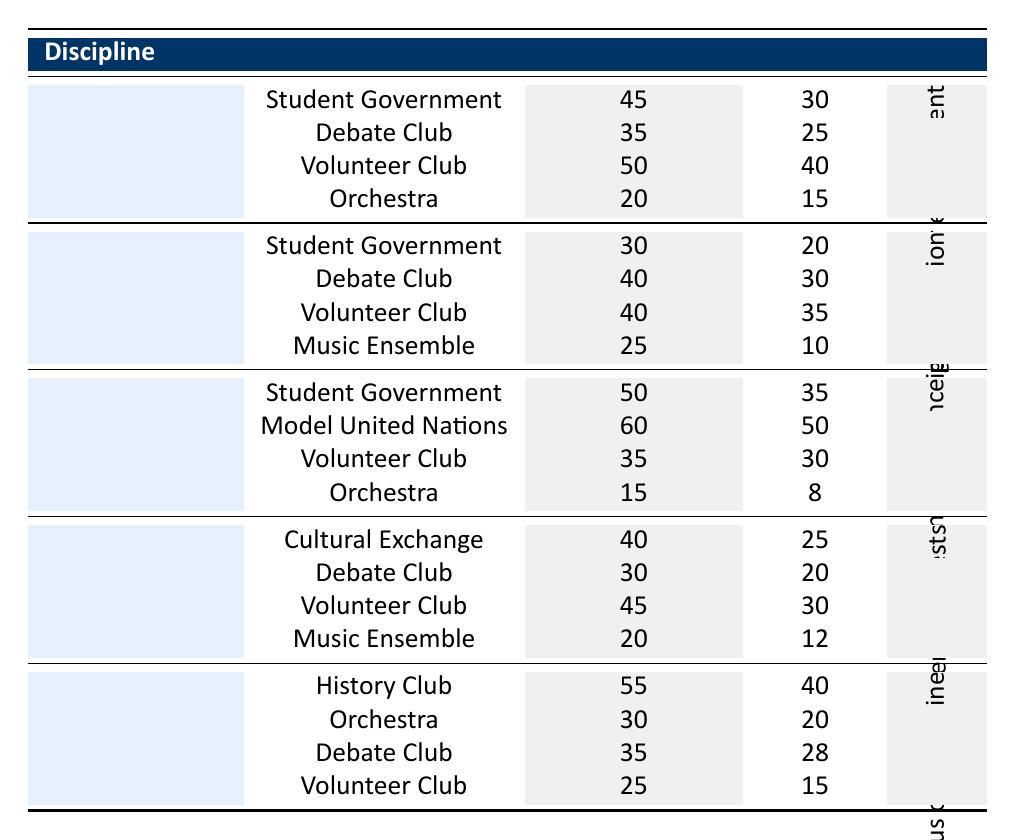What is the engagement percentage for Sociology in the Volunteer Club? The table shows that for Sociology in the Volunteer Club, the engagement percentage is listed as 50%.
Answer: 50% Which discipline has the highest engagement percentage in Student Government? In the table, Political Science has the highest engagement percentage in Student Government at 50%, compared to Sociology’s 45% and Psychology’s 30%.
Answer: Political Science How many members are there in the Debate Club for Sociology? The table indicates that the number of members in the Sociology Debate Club is 25.
Answer: 25 What is the average engagement percentage of all extracurricular activities for Sociology? To find the average: (45 + 35 + 50 + 20) / 4 = 150 / 4 = 37.5%.
Answer: 37.5% Does the Volunteer Club have a higher engagement percentage among Sociology or Psychology? In Sociology, the Volunteer Club has a 50% engagement ratio while in Psychology, it has 40%. Therefore, Sociology’s engagement percentage is higher.
Answer: Yes How many activities have an engagement percentage higher than 40% for Sociology? The activities with percentages higher than 40% for Sociology are the Student Government (45%), Debate Club (35%, not counted), and Volunteer Club (50%). Thus, there are 2 activities.
Answer: 2 What is the total number of members in the Sociology extracurricular activities? The total members in Sociology activities = 30 (Student Government) + 25 (Debate Club) + 40 (Volunteer Club) + 15 (Orchestra) = 110.
Answer: 110 Which activity has the lowest engagement percentage for the Sociology discipline? The table indicates that the Orchestra has the lowest engagement percentage for Sociology at 20%.
Answer: Orchestra What is the difference in member count between Sociology's Volunteer Club and Political Science's Model United Nations? Sociology’s Volunteer Club has 40 members and Political Science’s Model United Nations has 50 members. The difference is 50 - 40 = 10.
Answer: 10 Which discipline and activity combination has the highest engagement percentage? Examining the table, the highest engagement percentage is found in Political Science's Model United Nations with 60%.
Answer: Political Science, Model United Nations 